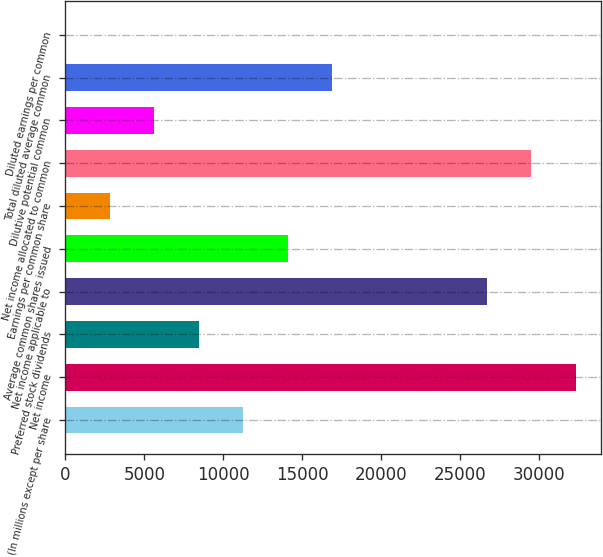<chart> <loc_0><loc_0><loc_500><loc_500><bar_chart><fcel>(In millions except per share<fcel>Net income<fcel>Preferred stock dividends<fcel>Net income applicable to<fcel>Average common shares issued<fcel>Earnings per common share<fcel>Net income allocated to common<fcel>Dilutive potential common<fcel>Total diluted average common<fcel>Diluted earnings per common<nl><fcel>11260.4<fcel>32324.9<fcel>8445.93<fcel>26696<fcel>14074.8<fcel>2817.05<fcel>29510.4<fcel>5631.49<fcel>16889.2<fcel>2.61<nl></chart> 